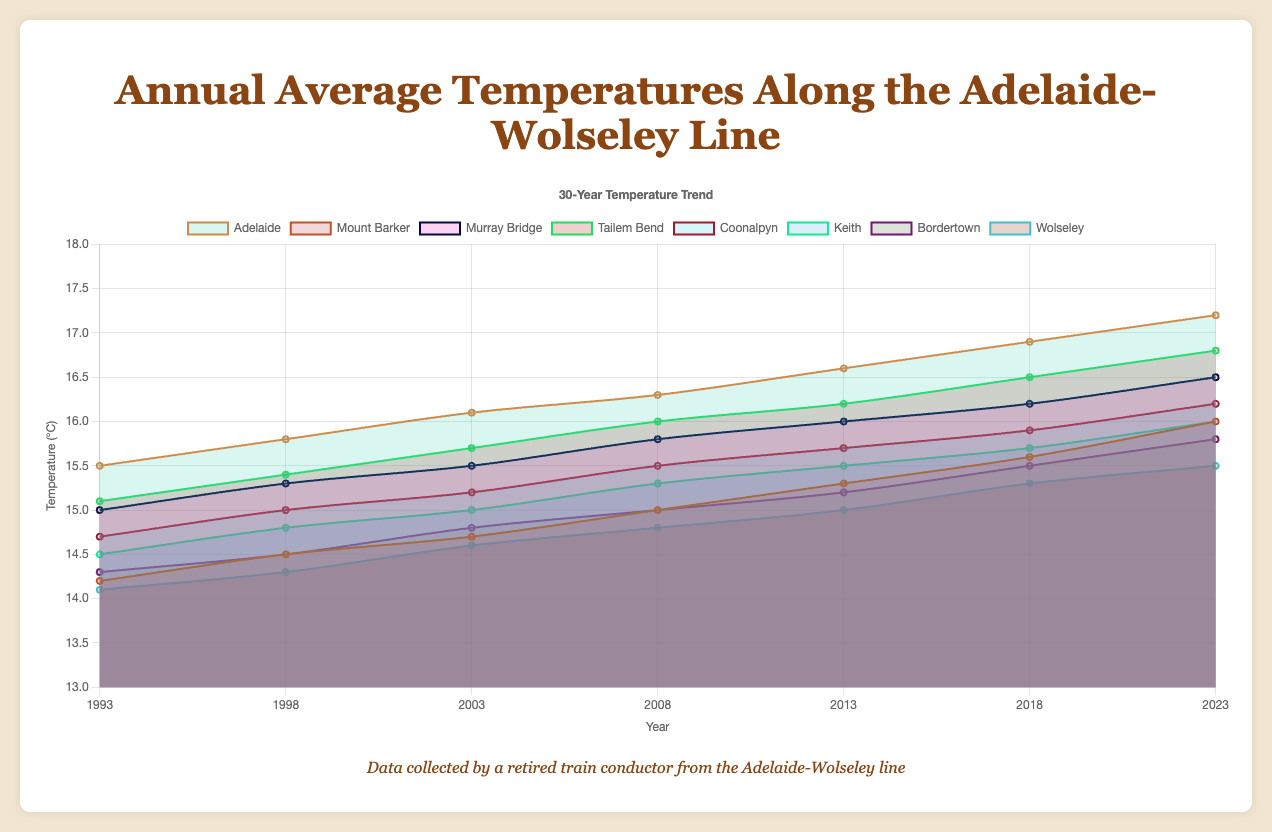What is the title of the chart? The title of the chart is prominently displayed at the top of the figure. It is "Annual Average Temperatures Along the Adelaide-Wolseley Line."
Answer: Annual Average Temperatures Along the Adelaide-Wolseley Line How many years are represented in the chart? By looking at the x-axis, which marks the years, we can count that there are seven years shown: 1993, 1998, 2003, 2008, 2013, 2018, and 2023.
Answer: 7 Which station shows the highest average temperature in 2023? Checking the 2023 column in the chart, Adelaide's temperature is the highest at 17.2°C, which is higher than any other station's temperature for the same year.
Answer: Adelaide What is the overall trend of temperatures from 1993 to 2023 for Mount Barker? The line for Mount Barker consistently rises from 14.2°C in 1993 to 16.0°C in 2023, indicating a gradual increase in average temperature over time.
Answer: Gradual increase Which station has the smallest range in recorded temperatures over the 30 years? To determine this, we find the difference between the highest and lowest temperatures for each station. The smallest range is found by checking each station's highest and lowest points. Wolseley ranges from 14.1°C to 15.5°C, which is a smaller range than other stations.
Answer: Wolseley What was the approximate difference in average temperature between Murray Bridge and Bordertown in 2003? In 2003, Murray Bridge's temperature was 15.5°C and Bordertown's was 14.8°C. The difference is calculated by subtracting Bordertown's temperature from Murray Bridge's temperature (15.5 - 14.8).
Answer: 0.7°C Which two stations had the most similar temperatures in 2018? Check the values for each station in 2018. Coonalpyn and Keith both had temperatures close to each other, with 15.9°C and 15.7°C respectively, indicating the most similarity.
Answer: Coonalpyn and Keith Which station has seen the largest increase in average temperature from 1993 to 2023? Calculating the difference between the 2023 and 1993 temperatures for each station, we find Adelaide increased from 15.5°C to 17.2°C (an increase of 1.7°C), which is the largest among all stations.
Answer: Adelaide Rank the stations based on their 2023 temperatures, from highest to lowest. The 2023 temperatures are: Adelaide (17.2°C), Tailem Bend (16.8°C), Mount Barker (16.0°C), Keith (16.0°C), Murray Bridge (16.5°C), Coonalpyn (16.2°C), Bordertown (15.8°C), and Wolseley (15.5°C). Ranking them: Adelaide, Tailem Bend, Mount Barker/Keith, Murray Bridge, Coonalpyn, Bordertown, Wolseley.
Answer: Adelaide, Tailem Bend, Murray Bridge, Coonalpyn, Keith, Mount Barker, Bordertown, Wolseley Describe how the average temperatures of all stations changed from 1993 to 2023. Looking at all the lines on the chart, each station shows an upward trend, meaning the average temperature has increased uniformly across all stations over the 30-year period.
Answer: Increased uniformly 